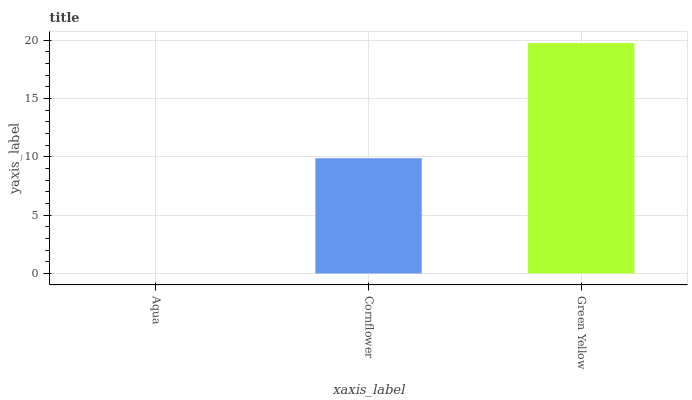Is Aqua the minimum?
Answer yes or no. Yes. Is Green Yellow the maximum?
Answer yes or no. Yes. Is Cornflower the minimum?
Answer yes or no. No. Is Cornflower the maximum?
Answer yes or no. No. Is Cornflower greater than Aqua?
Answer yes or no. Yes. Is Aqua less than Cornflower?
Answer yes or no. Yes. Is Aqua greater than Cornflower?
Answer yes or no. No. Is Cornflower less than Aqua?
Answer yes or no. No. Is Cornflower the high median?
Answer yes or no. Yes. Is Cornflower the low median?
Answer yes or no. Yes. Is Green Yellow the high median?
Answer yes or no. No. Is Aqua the low median?
Answer yes or no. No. 